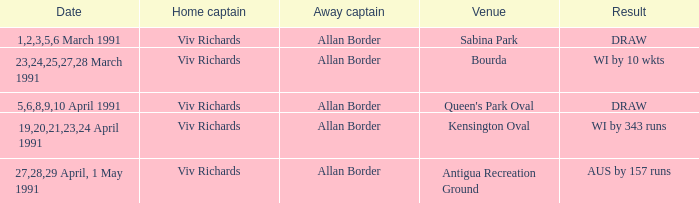Which venues resulted in a draw? Sabina Park, Queen's Park Oval. 